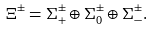Convert formula to latex. <formula><loc_0><loc_0><loc_500><loc_500>\Xi ^ { \pm } = { \Sigma } ^ { \pm } _ { + } \oplus { \Sigma } ^ { \pm } _ { 0 } \oplus { \Sigma } ^ { \pm } _ { - } .</formula> 